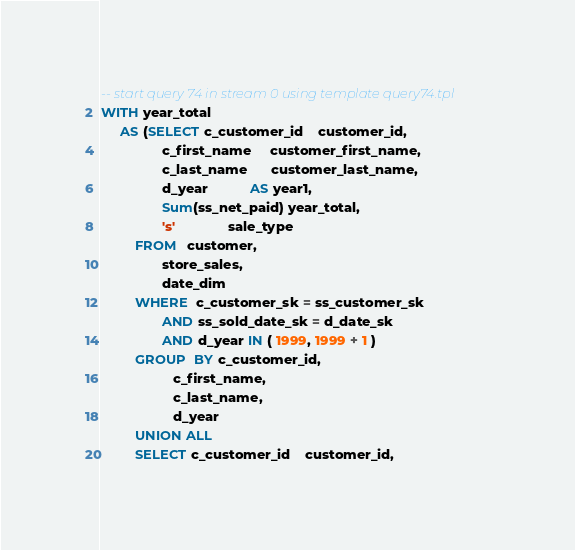<code> <loc_0><loc_0><loc_500><loc_500><_SQL_>-- start query 74 in stream 0 using template query74.tpl 
WITH year_total 
     AS (SELECT c_customer_id    customer_id, 
                c_first_name     customer_first_name, 
                c_last_name      customer_last_name, 
                d_year           AS year1, 
                Sum(ss_net_paid) year_total, 
                's'              sale_type 
         FROM   customer, 
                store_sales, 
                date_dim 
         WHERE  c_customer_sk = ss_customer_sk 
                AND ss_sold_date_sk = d_date_sk 
                AND d_year IN ( 1999, 1999 + 1 ) 
         GROUP  BY c_customer_id, 
                   c_first_name, 
                   c_last_name, 
                   d_year 
         UNION ALL 
         SELECT c_customer_id    customer_id, </code> 